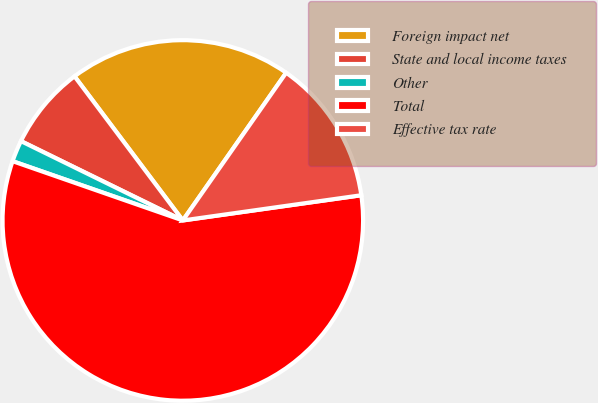Convert chart. <chart><loc_0><loc_0><loc_500><loc_500><pie_chart><fcel>Foreign impact net<fcel>State and local income taxes<fcel>Other<fcel>Total<fcel>Effective tax rate<nl><fcel>19.97%<fcel>7.49%<fcel>1.92%<fcel>57.56%<fcel>13.05%<nl></chart> 